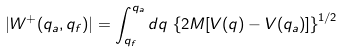<formula> <loc_0><loc_0><loc_500><loc_500>| W ^ { + } ( q _ { a } , q _ { f } ) | = \int _ { q _ { f } } ^ { q _ { a } } d q \, \left \{ 2 M [ V ( q ) - V ( q _ { a } ) ] \right \} ^ { 1 / 2 }</formula> 